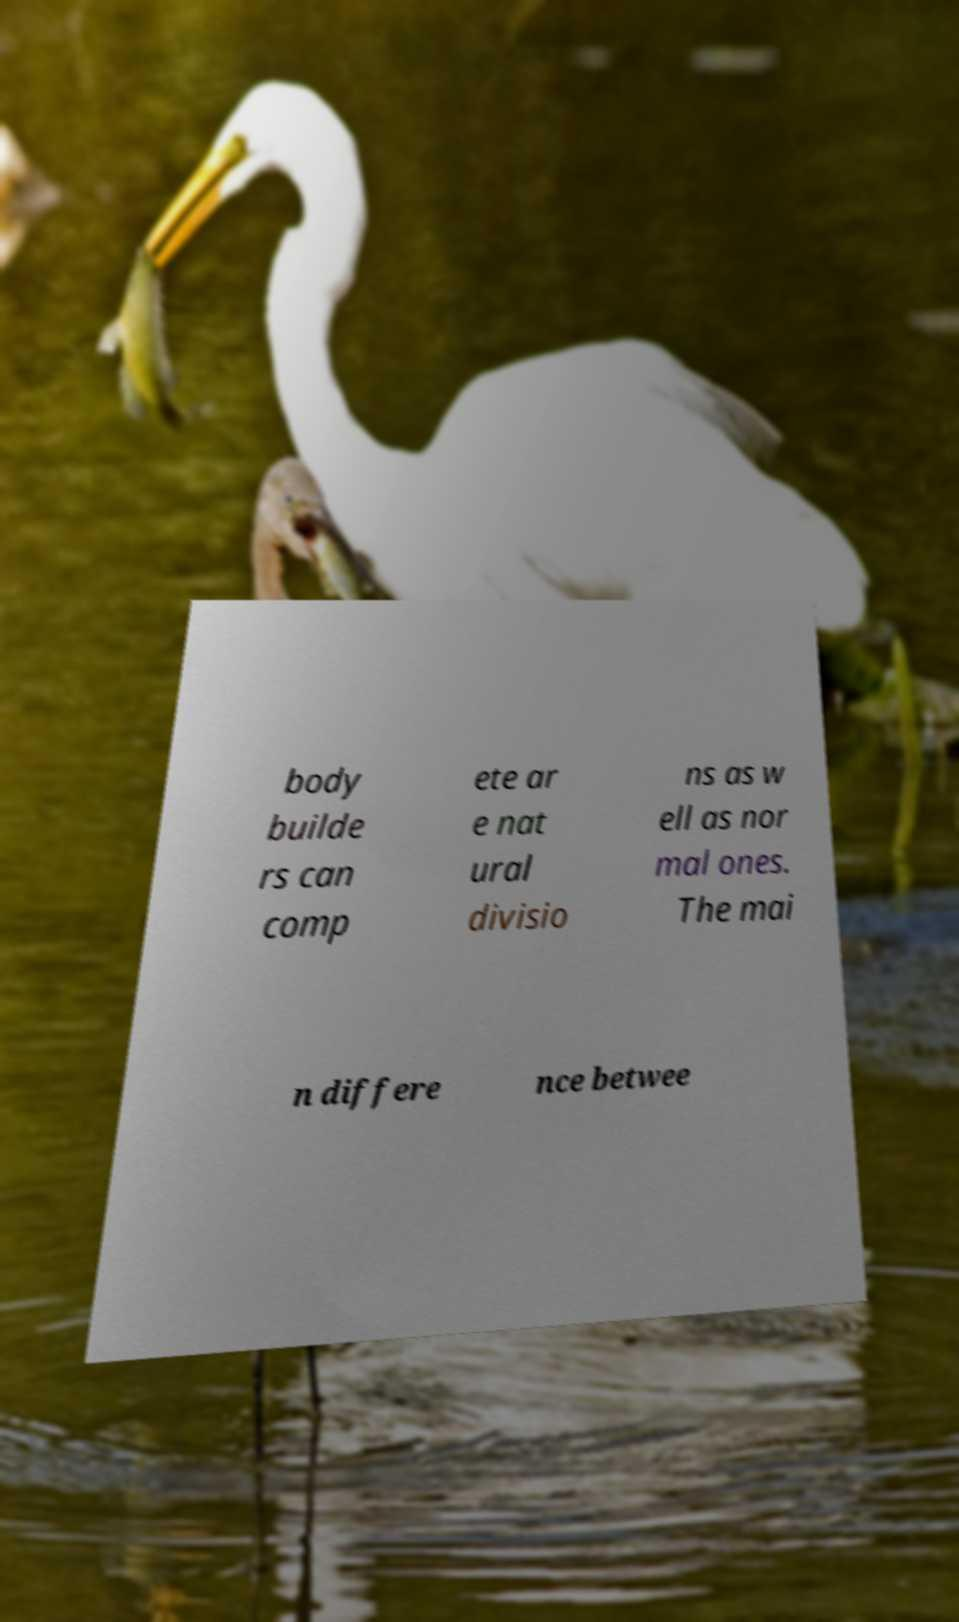What messages or text are displayed in this image? I need them in a readable, typed format. body builde rs can comp ete ar e nat ural divisio ns as w ell as nor mal ones. The mai n differe nce betwee 